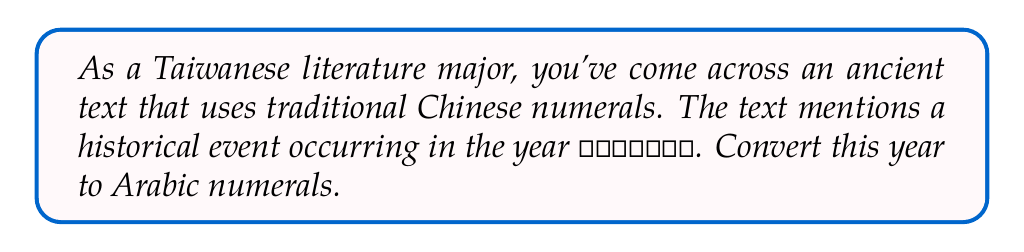Could you help me with this problem? To convert traditional Chinese numerals to Arabic numerals, we need to understand the place value system used in Chinese numerals and map each character to its corresponding Arabic numeral value. Let's break it down step-by-step:

1. Identify the numerals and their place values:
   壹 (yī) = 1
   仟 (qiān) = thousand (1000)
   玖 (jiǔ) = 9
   佰 (bǎi) = hundred (100)
   陸 (liù) = 6
   拾 (shí) = ten (10)
   參 (sān) = 3

2. Calculate the value for each component:
   壹仟 = $1 \times 1000 = 1000$
   玖佰 = $9 \times 100 = 900$
   陸拾 = $6 \times 10 = 60$
   參 = $3$

3. Sum up all the components:
   $1000 + 900 + 60 + 3 = 1963$

Therefore, the year 壹仟玖佰陸拾參 in traditional Chinese numerals is equivalent to 1963 in Arabic numerals.
Answer: 1963 